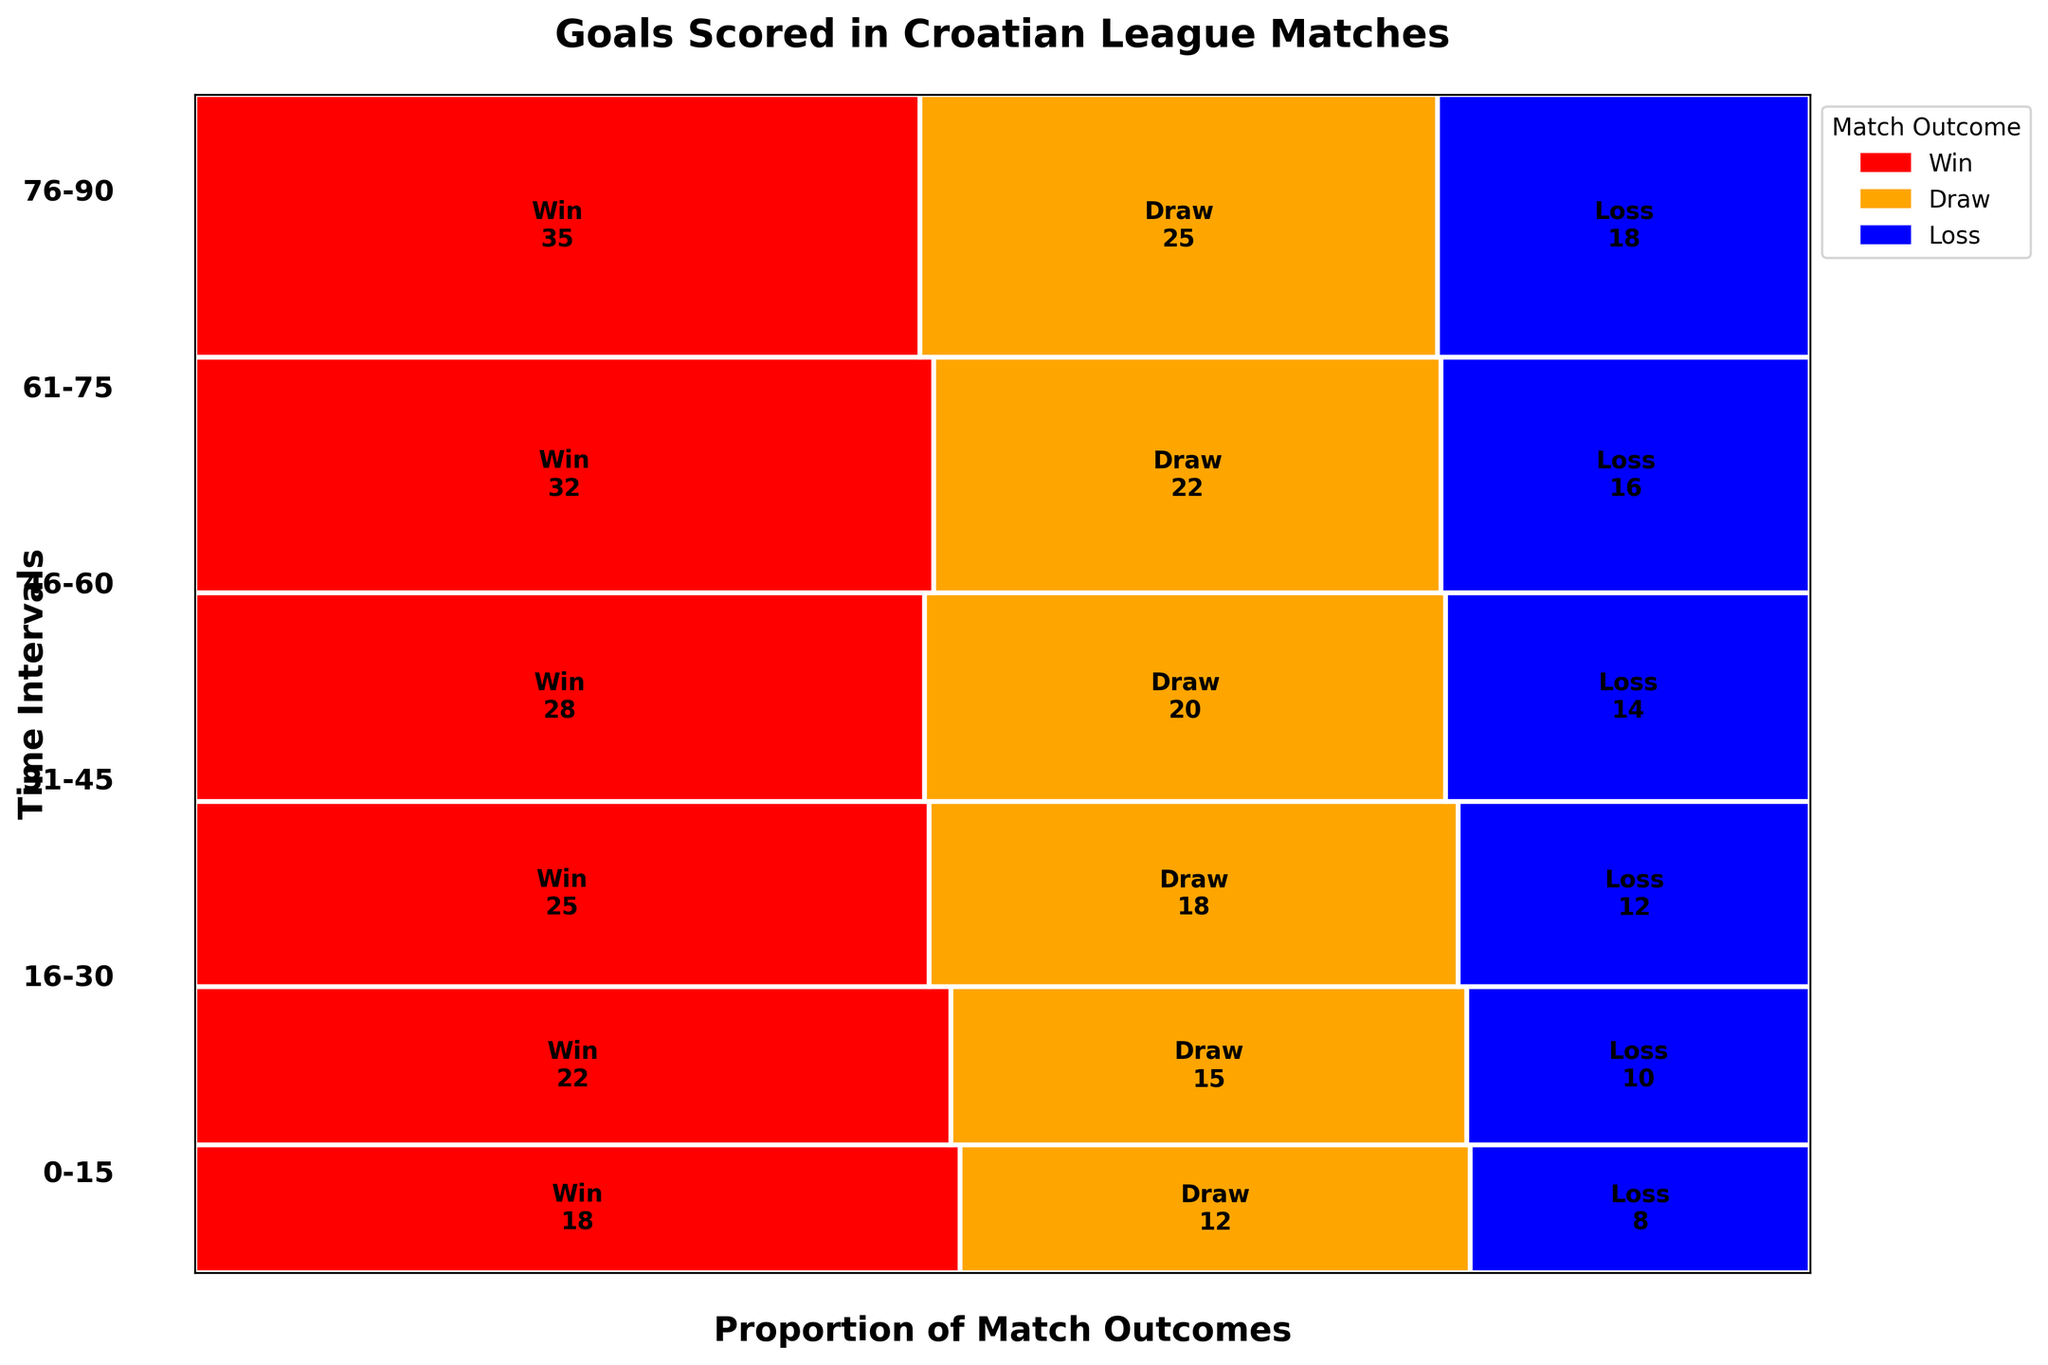What is the title of the plot? The title is typically displayed at the top of the plot in a larger, bold font to summarize what the plot is about.
Answer: Goals Scored in Croatian League Matches Which time interval has the highest total number of goals scored? To find the time interval with the highest number of goals, look at the interval with the largest summation of counts across all outcomes (Win, Draw, and Loss).
Answer: 76-90 What is the predominant match outcome in the 46-60 minute interval? The predominant match outcome is the one that occupies the widest portion of the time interval's rectangle. In the 46-60 minute interval, the outcome with the most space is "Win".
Answer: Win Compare the number of goals scored in the 0-15 and 76-90 minute intervals. Which has more draws? To compare the draws between the two intervals, look at the part of the rectangles labeled "Draw" for 0-15 and 76-90 minutes. The height showing "Draw" in the 76-90 minute interval is larger.
Answer: 76-90 During which time interval are losses the least common? To determine this, look for the time interval where the blue rectangle representing “Loss” has the smallest width. It is narrowest in the 0-15 minute interval.
Answer: 0-15 How does the proportion of drew outcomes change from the 16-30 to the 76-90 minute intervals? Observe the width of the orange-colored rectangles for "Draw" outcomes in each specified time interval. The width for the "Draw" outcome increases from 16-30 to 76-90, indicating an increase in the proportion.
Answer: Increases What is the proportion of wins in the 31-45 minute interval relative to other outcomes? In the 31-45 minute interval, find the width of the red section for "Win" and compare it to the combined width of the sections for "Draw" and "Loss". The "Win" proportion is the largest compared to the other two outcomes.
Answer: Largest proportion Are there more goals scored in wins or losses for the 61-75 minute interval? Compare the height of the red rectangle for "Win" and the blue rectangle for "Loss" in the 61-75 minute interval. The height for "Win" is larger, indicating more goals.
Answer: Wins What can you infer about the trend of goal scoring as time progresses in the match? By observing the heights and widths of rectangles across all intervals, one can infer that as time progresses, more goals are scored, and wins are increasingly common in later intervals.
Answer: More goals and wins in later intervals During which time interval are draws equally common to losses? Look for a time interval where the widths of the orange ("Draw") and blue ("Loss") rectangles are approximately equal. The 0-15 minute interval meets this condition.
Answer: 0-15 